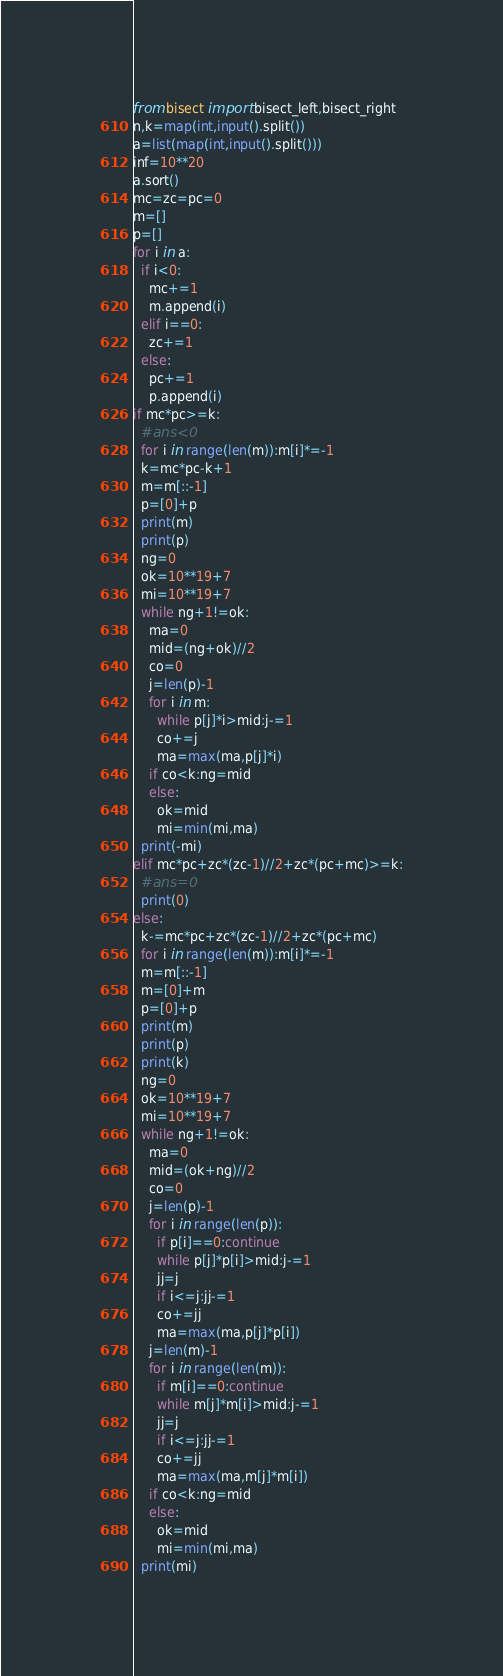<code> <loc_0><loc_0><loc_500><loc_500><_Python_>from bisect import bisect_left,bisect_right
n,k=map(int,input().split())
a=list(map(int,input().split()))
inf=10**20
a.sort()
mc=zc=pc=0
m=[]
p=[]
for i in a:
  if i<0:
    mc+=1
    m.append(i)
  elif i==0:
    zc+=1
  else:
    pc+=1
    p.append(i)
if mc*pc>=k:
  #ans<0
  for i in range(len(m)):m[i]*=-1
  k=mc*pc-k+1
  m=m[::-1]
  p=[0]+p
  print(m)
  print(p)
  ng=0
  ok=10**19+7
  mi=10**19+7
  while ng+1!=ok:
    ma=0
    mid=(ng+ok)//2
    co=0
    j=len(p)-1
    for i in m:
      while p[j]*i>mid:j-=1
      co+=j
      ma=max(ma,p[j]*i)
    if co<k:ng=mid
    else:
      ok=mid
      mi=min(mi,ma)
  print(-mi)
elif mc*pc+zc*(zc-1)//2+zc*(pc+mc)>=k:
  #ans=0
  print(0)
else:
  k-=mc*pc+zc*(zc-1)//2+zc*(pc+mc)
  for i in range(len(m)):m[i]*=-1
  m=m[::-1]
  m=[0]+m
  p=[0]+p
  print(m)
  print(p)
  print(k)
  ng=0
  ok=10**19+7
  mi=10**19+7
  while ng+1!=ok:
    ma=0
    mid=(ok+ng)//2
    co=0
    j=len(p)-1
    for i in range(len(p)):
      if p[i]==0:continue
      while p[j]*p[i]>mid:j-=1
      jj=j
      if i<=j:jj-=1
      co+=jj
      ma=max(ma,p[j]*p[i])
    j=len(m)-1
    for i in range(len(m)):
      if m[i]==0:continue
      while m[j]*m[i]>mid:j-=1
      jj=j
      if i<=j:jj-=1
      co+=jj
      ma=max(ma,m[j]*m[i])
    if co<k:ng=mid
    else:
      ok=mid
      mi=min(mi,ma)
  print(mi)</code> 